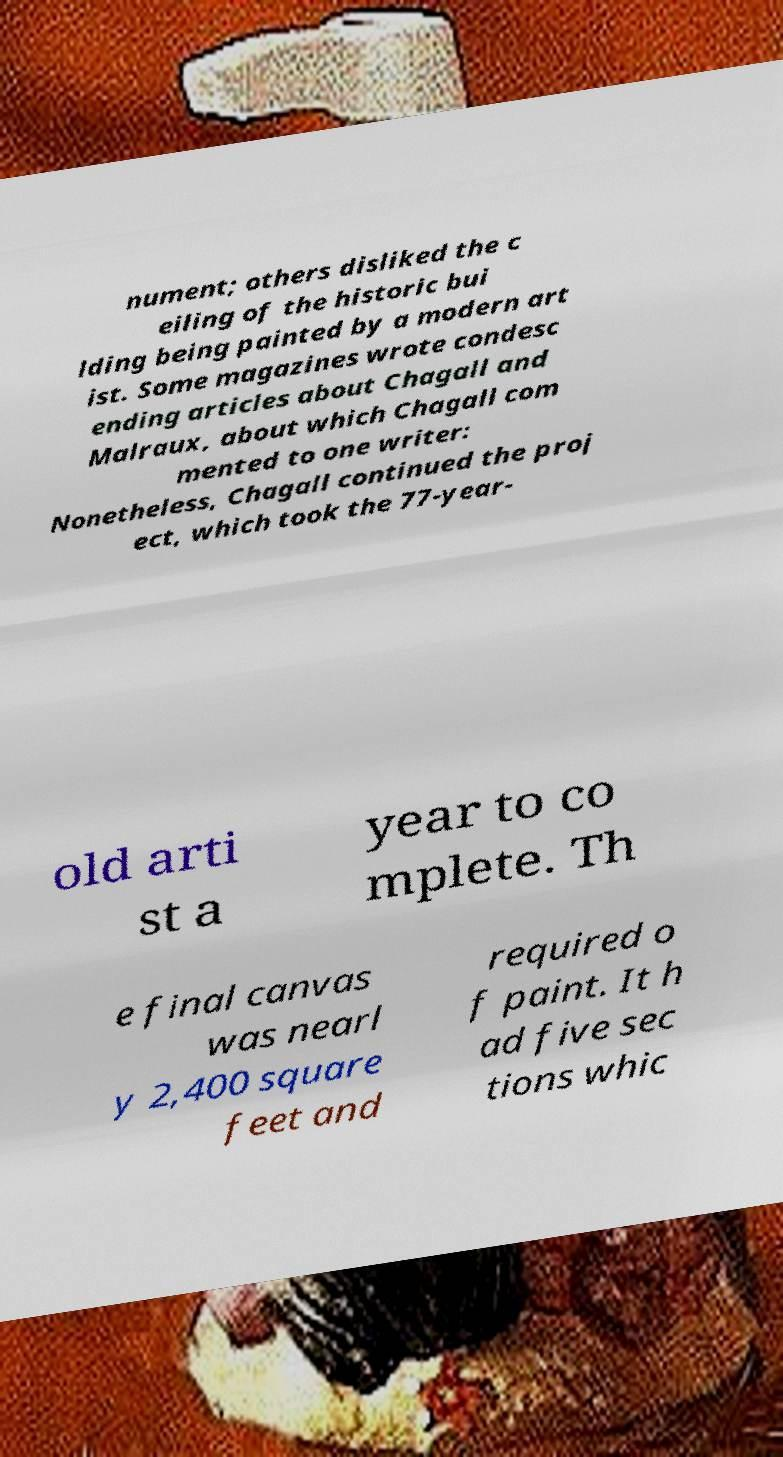Could you extract and type out the text from this image? nument; others disliked the c eiling of the historic bui lding being painted by a modern art ist. Some magazines wrote condesc ending articles about Chagall and Malraux, about which Chagall com mented to one writer: Nonetheless, Chagall continued the proj ect, which took the 77-year- old arti st a year to co mplete. Th e final canvas was nearl y 2,400 square feet and required o f paint. It h ad five sec tions whic 